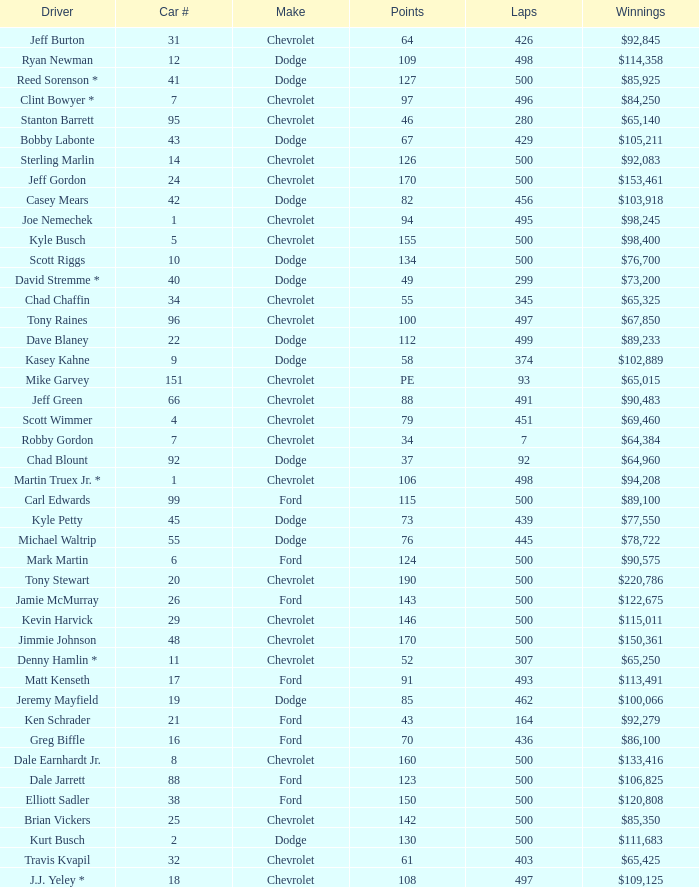What is the average car number of all the drivers who have won $111,683? 2.0. Can you parse all the data within this table? {'header': ['Driver', 'Car #', 'Make', 'Points', 'Laps', 'Winnings'], 'rows': [['Jeff Burton', '31', 'Chevrolet', '64', '426', '$92,845'], ['Ryan Newman', '12', 'Dodge', '109', '498', '$114,358'], ['Reed Sorenson *', '41', 'Dodge', '127', '500', '$85,925'], ['Clint Bowyer *', '7', 'Chevrolet', '97', '496', '$84,250'], ['Stanton Barrett', '95', 'Chevrolet', '46', '280', '$65,140'], ['Bobby Labonte', '43', 'Dodge', '67', '429', '$105,211'], ['Sterling Marlin', '14', 'Chevrolet', '126', '500', '$92,083'], ['Jeff Gordon', '24', 'Chevrolet', '170', '500', '$153,461'], ['Casey Mears', '42', 'Dodge', '82', '456', '$103,918'], ['Joe Nemechek', '1', 'Chevrolet', '94', '495', '$98,245'], ['Kyle Busch', '5', 'Chevrolet', '155', '500', '$98,400'], ['Scott Riggs', '10', 'Dodge', '134', '500', '$76,700'], ['David Stremme *', '40', 'Dodge', '49', '299', '$73,200'], ['Chad Chaffin', '34', 'Chevrolet', '55', '345', '$65,325'], ['Tony Raines', '96', 'Chevrolet', '100', '497', '$67,850'], ['Dave Blaney', '22', 'Dodge', '112', '499', '$89,233'], ['Kasey Kahne', '9', 'Dodge', '58', '374', '$102,889'], ['Mike Garvey', '151', 'Chevrolet', 'PE', '93', '$65,015'], ['Jeff Green', '66', 'Chevrolet', '88', '491', '$90,483'], ['Scott Wimmer', '4', 'Chevrolet', '79', '451', '$69,460'], ['Robby Gordon', '7', 'Chevrolet', '34', '7', '$64,384'], ['Chad Blount', '92', 'Dodge', '37', '92', '$64,960'], ['Martin Truex Jr. *', '1', 'Chevrolet', '106', '498', '$94,208'], ['Carl Edwards', '99', 'Ford', '115', '500', '$89,100'], ['Kyle Petty', '45', 'Dodge', '73', '439', '$77,550'], ['Michael Waltrip', '55', 'Dodge', '76', '445', '$78,722'], ['Mark Martin', '6', 'Ford', '124', '500', '$90,575'], ['Tony Stewart', '20', 'Chevrolet', '190', '500', '$220,786'], ['Jamie McMurray', '26', 'Ford', '143', '500', '$122,675'], ['Kevin Harvick', '29', 'Chevrolet', '146', '500', '$115,011'], ['Jimmie Johnson', '48', 'Chevrolet', '170', '500', '$150,361'], ['Denny Hamlin *', '11', 'Chevrolet', '52', '307', '$65,250'], ['Matt Kenseth', '17', 'Ford', '91', '493', '$113,491'], ['Jeremy Mayfield', '19', 'Dodge', '85', '462', '$100,066'], ['Ken Schrader', '21', 'Ford', '43', '164', '$92,279'], ['Greg Biffle', '16', 'Ford', '70', '436', '$86,100'], ['Dale Earnhardt Jr.', '8', 'Chevrolet', '160', '500', '$133,416'], ['Dale Jarrett', '88', 'Ford', '123', '500', '$106,825'], ['Elliott Sadler', '38', 'Ford', '150', '500', '$120,808'], ['Brian Vickers', '25', 'Chevrolet', '142', '500', '$85,350'], ['Kurt Busch', '2', 'Dodge', '130', '500', '$111,683'], ['Travis Kvapil', '32', 'Chevrolet', '61', '403', '$65,425'], ['J.J. Yeley *', '18', 'Chevrolet', '108', '497', '$109,125']]} 